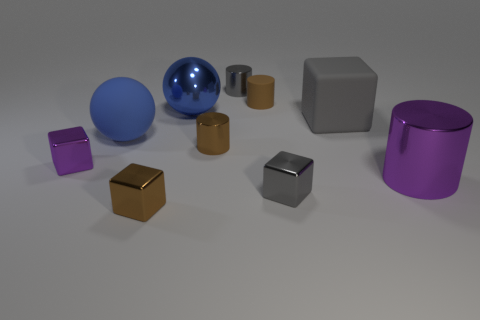Subtract 1 cubes. How many cubes are left? 3 Subtract all blocks. How many objects are left? 6 Add 3 large cyan matte objects. How many large cyan matte objects exist? 3 Subtract 1 blue spheres. How many objects are left? 9 Subtract all big cubes. Subtract all brown rubber objects. How many objects are left? 8 Add 9 rubber blocks. How many rubber blocks are left? 10 